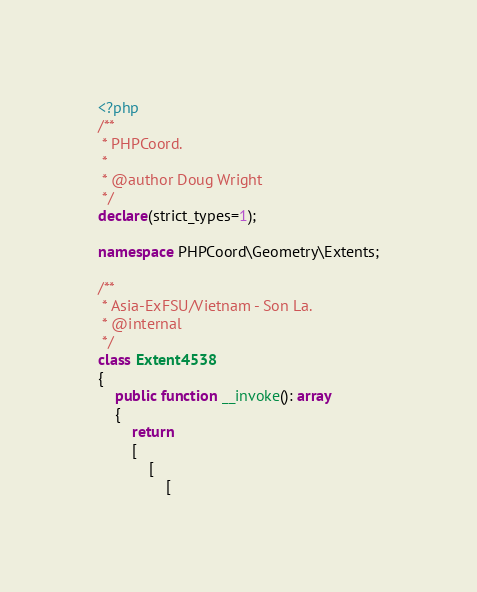Convert code to text. <code><loc_0><loc_0><loc_500><loc_500><_PHP_><?php
/**
 * PHPCoord.
 *
 * @author Doug Wright
 */
declare(strict_types=1);

namespace PHPCoord\Geometry\Extents;

/**
 * Asia-ExFSU/Vietnam - Son La.
 * @internal
 */
class Extent4538
{
    public function __invoke(): array
    {
        return
        [
            [
                [</code> 